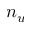<formula> <loc_0><loc_0><loc_500><loc_500>n _ { u }</formula> 